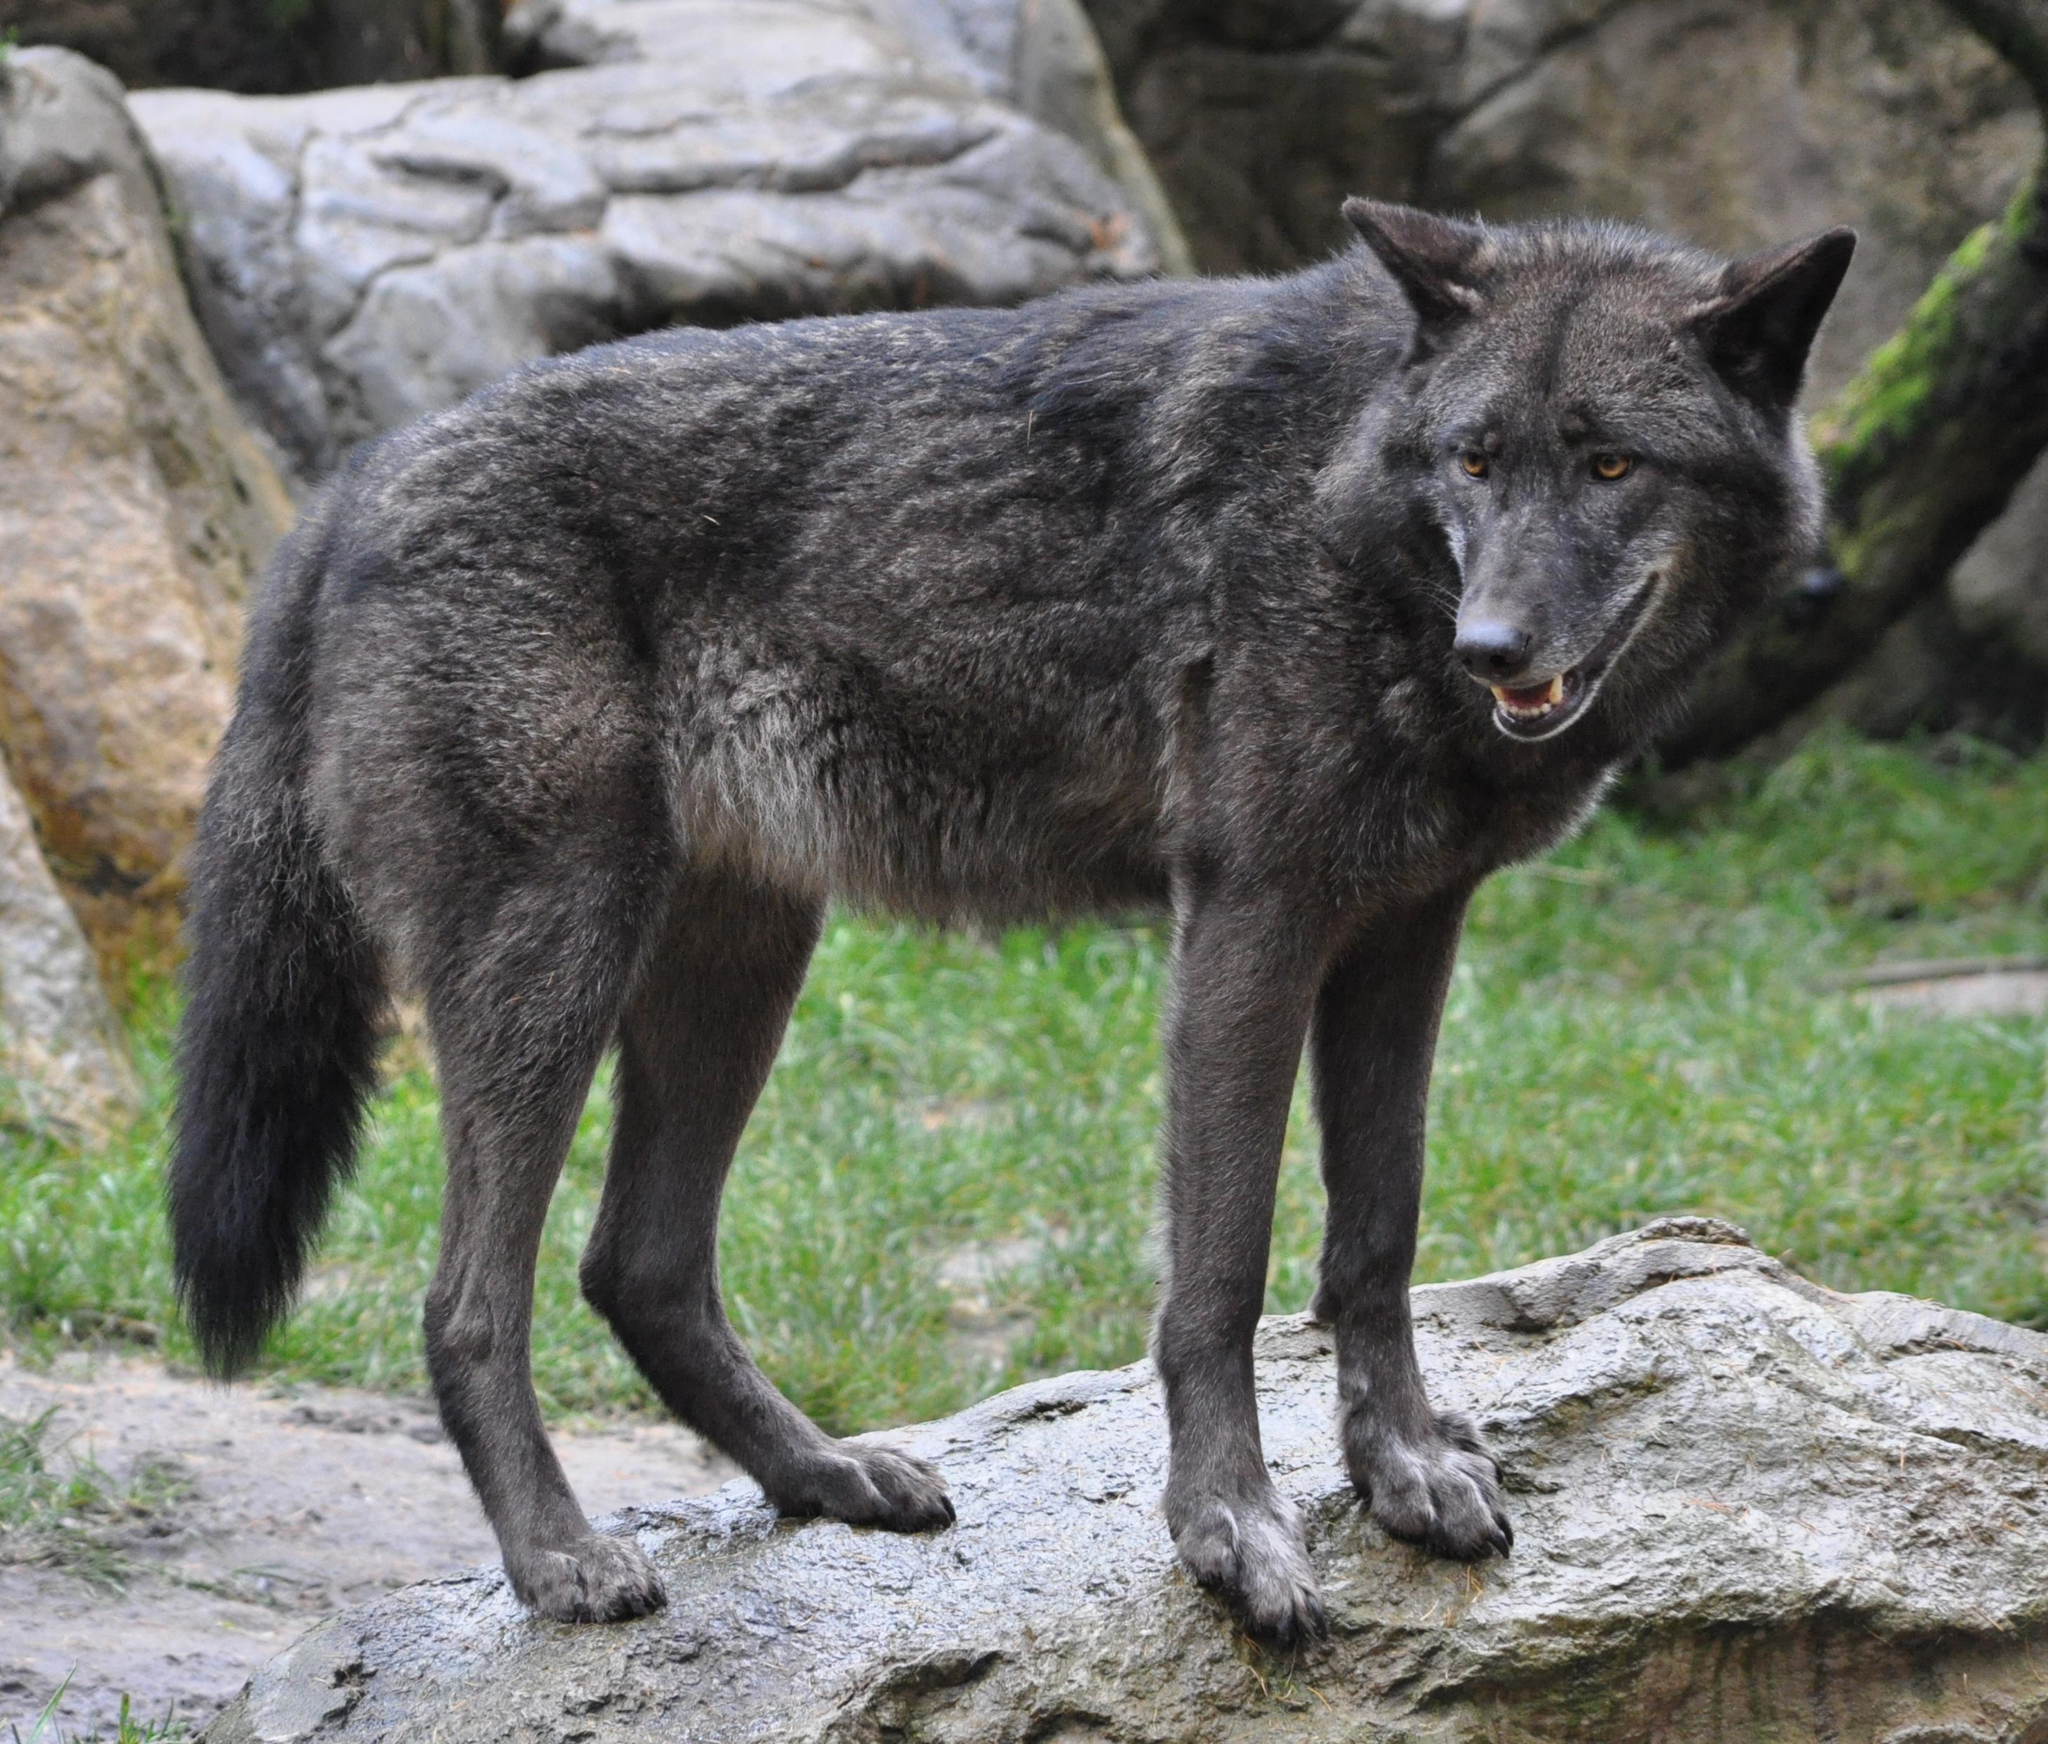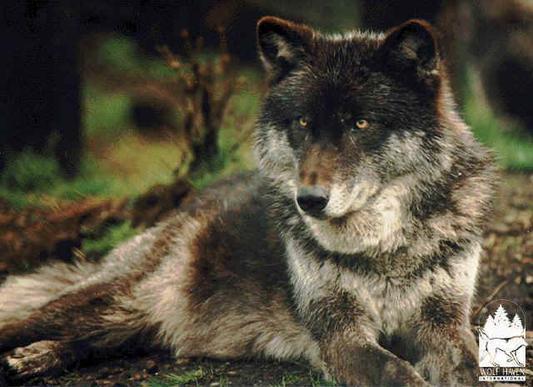The first image is the image on the left, the second image is the image on the right. For the images shown, is this caption "One of the wolves is howling facing left." true? Answer yes or no. No. The first image is the image on the left, the second image is the image on the right. Considering the images on both sides, is "The right image includes a rightward-turned wolf with its head and neck raised, eyes closed, and mouth open in a howling pose." valid? Answer yes or no. No. 